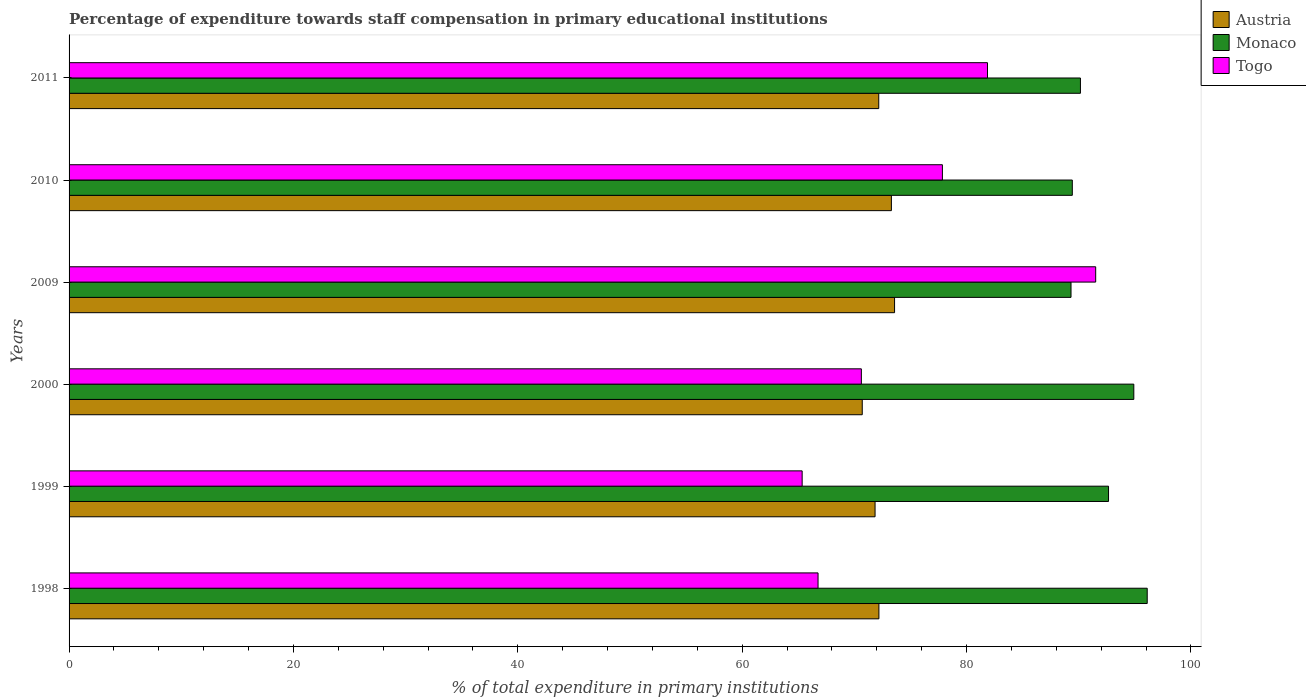How many different coloured bars are there?
Keep it short and to the point. 3. Are the number of bars per tick equal to the number of legend labels?
Make the answer very short. Yes. How many bars are there on the 1st tick from the bottom?
Your answer should be compact. 3. What is the label of the 2nd group of bars from the top?
Provide a succinct answer. 2010. In how many cases, is the number of bars for a given year not equal to the number of legend labels?
Provide a succinct answer. 0. What is the percentage of expenditure towards staff compensation in Monaco in 2000?
Offer a terse response. 94.91. Across all years, what is the maximum percentage of expenditure towards staff compensation in Austria?
Offer a terse response. 73.58. Across all years, what is the minimum percentage of expenditure towards staff compensation in Togo?
Offer a very short reply. 65.34. What is the total percentage of expenditure towards staff compensation in Togo in the graph?
Your answer should be very brief. 453.95. What is the difference between the percentage of expenditure towards staff compensation in Monaco in 2000 and that in 2011?
Keep it short and to the point. 4.76. What is the difference between the percentage of expenditure towards staff compensation in Togo in 2010 and the percentage of expenditure towards staff compensation in Monaco in 2009?
Your answer should be very brief. -11.46. What is the average percentage of expenditure towards staff compensation in Togo per year?
Offer a very short reply. 75.66. In the year 1999, what is the difference between the percentage of expenditure towards staff compensation in Togo and percentage of expenditure towards staff compensation in Austria?
Offer a very short reply. -6.5. What is the ratio of the percentage of expenditure towards staff compensation in Monaco in 2000 to that in 2011?
Provide a short and direct response. 1.05. Is the percentage of expenditure towards staff compensation in Togo in 1998 less than that in 2011?
Offer a very short reply. Yes. Is the difference between the percentage of expenditure towards staff compensation in Togo in 1998 and 2009 greater than the difference between the percentage of expenditure towards staff compensation in Austria in 1998 and 2009?
Your answer should be very brief. No. What is the difference between the highest and the second highest percentage of expenditure towards staff compensation in Austria?
Offer a very short reply. 0.28. What is the difference between the highest and the lowest percentage of expenditure towards staff compensation in Austria?
Provide a succinct answer. 2.88. In how many years, is the percentage of expenditure towards staff compensation in Togo greater than the average percentage of expenditure towards staff compensation in Togo taken over all years?
Your answer should be very brief. 3. Is the sum of the percentage of expenditure towards staff compensation in Austria in 1999 and 2000 greater than the maximum percentage of expenditure towards staff compensation in Monaco across all years?
Make the answer very short. Yes. What does the 1st bar from the top in 2010 represents?
Give a very brief answer. Togo. Is it the case that in every year, the sum of the percentage of expenditure towards staff compensation in Togo and percentage of expenditure towards staff compensation in Monaco is greater than the percentage of expenditure towards staff compensation in Austria?
Your response must be concise. Yes. How many years are there in the graph?
Offer a terse response. 6. Does the graph contain any zero values?
Make the answer very short. No. Does the graph contain grids?
Provide a short and direct response. No. How are the legend labels stacked?
Keep it short and to the point. Vertical. What is the title of the graph?
Make the answer very short. Percentage of expenditure towards staff compensation in primary educational institutions. What is the label or title of the X-axis?
Provide a succinct answer. % of total expenditure in primary institutions. What is the % of total expenditure in primary institutions in Austria in 1998?
Offer a very short reply. 72.19. What is the % of total expenditure in primary institutions of Monaco in 1998?
Your response must be concise. 96.1. What is the % of total expenditure in primary institutions in Togo in 1998?
Offer a very short reply. 66.76. What is the % of total expenditure in primary institutions of Austria in 1999?
Give a very brief answer. 71.84. What is the % of total expenditure in primary institutions in Monaco in 1999?
Your answer should be compact. 92.65. What is the % of total expenditure in primary institutions of Togo in 1999?
Make the answer very short. 65.34. What is the % of total expenditure in primary institutions in Austria in 2000?
Keep it short and to the point. 70.7. What is the % of total expenditure in primary institutions of Monaco in 2000?
Ensure brevity in your answer.  94.91. What is the % of total expenditure in primary institutions in Togo in 2000?
Make the answer very short. 70.62. What is the % of total expenditure in primary institutions in Austria in 2009?
Give a very brief answer. 73.58. What is the % of total expenditure in primary institutions in Monaco in 2009?
Provide a succinct answer. 89.31. What is the % of total expenditure in primary institutions in Togo in 2009?
Give a very brief answer. 91.51. What is the % of total expenditure in primary institutions in Austria in 2010?
Provide a short and direct response. 73.3. What is the % of total expenditure in primary institutions in Monaco in 2010?
Make the answer very short. 89.43. What is the % of total expenditure in primary institutions of Togo in 2010?
Give a very brief answer. 77.85. What is the % of total expenditure in primary institutions of Austria in 2011?
Your answer should be very brief. 72.17. What is the % of total expenditure in primary institutions in Monaco in 2011?
Offer a terse response. 90.15. What is the % of total expenditure in primary institutions of Togo in 2011?
Offer a terse response. 81.87. Across all years, what is the maximum % of total expenditure in primary institutions of Austria?
Keep it short and to the point. 73.58. Across all years, what is the maximum % of total expenditure in primary institutions in Monaco?
Offer a terse response. 96.1. Across all years, what is the maximum % of total expenditure in primary institutions of Togo?
Ensure brevity in your answer.  91.51. Across all years, what is the minimum % of total expenditure in primary institutions in Austria?
Provide a succinct answer. 70.7. Across all years, what is the minimum % of total expenditure in primary institutions of Monaco?
Provide a succinct answer. 89.31. Across all years, what is the minimum % of total expenditure in primary institutions in Togo?
Give a very brief answer. 65.34. What is the total % of total expenditure in primary institutions of Austria in the graph?
Provide a succinct answer. 433.79. What is the total % of total expenditure in primary institutions in Monaco in the graph?
Your answer should be very brief. 552.55. What is the total % of total expenditure in primary institutions of Togo in the graph?
Make the answer very short. 453.95. What is the difference between the % of total expenditure in primary institutions of Austria in 1998 and that in 1999?
Provide a short and direct response. 0.34. What is the difference between the % of total expenditure in primary institutions of Monaco in 1998 and that in 1999?
Keep it short and to the point. 3.45. What is the difference between the % of total expenditure in primary institutions of Togo in 1998 and that in 1999?
Give a very brief answer. 1.42. What is the difference between the % of total expenditure in primary institutions of Austria in 1998 and that in 2000?
Give a very brief answer. 1.49. What is the difference between the % of total expenditure in primary institutions of Monaco in 1998 and that in 2000?
Provide a short and direct response. 1.2. What is the difference between the % of total expenditure in primary institutions in Togo in 1998 and that in 2000?
Give a very brief answer. -3.86. What is the difference between the % of total expenditure in primary institutions in Austria in 1998 and that in 2009?
Provide a succinct answer. -1.4. What is the difference between the % of total expenditure in primary institutions of Monaco in 1998 and that in 2009?
Provide a short and direct response. 6.79. What is the difference between the % of total expenditure in primary institutions in Togo in 1998 and that in 2009?
Offer a terse response. -24.75. What is the difference between the % of total expenditure in primary institutions in Austria in 1998 and that in 2010?
Provide a short and direct response. -1.11. What is the difference between the % of total expenditure in primary institutions in Monaco in 1998 and that in 2010?
Give a very brief answer. 6.68. What is the difference between the % of total expenditure in primary institutions of Togo in 1998 and that in 2010?
Your answer should be very brief. -11.08. What is the difference between the % of total expenditure in primary institutions of Austria in 1998 and that in 2011?
Your answer should be very brief. 0.02. What is the difference between the % of total expenditure in primary institutions of Monaco in 1998 and that in 2011?
Give a very brief answer. 5.95. What is the difference between the % of total expenditure in primary institutions of Togo in 1998 and that in 2011?
Keep it short and to the point. -15.1. What is the difference between the % of total expenditure in primary institutions in Austria in 1999 and that in 2000?
Your response must be concise. 1.14. What is the difference between the % of total expenditure in primary institutions in Monaco in 1999 and that in 2000?
Provide a succinct answer. -2.25. What is the difference between the % of total expenditure in primary institutions of Togo in 1999 and that in 2000?
Keep it short and to the point. -5.28. What is the difference between the % of total expenditure in primary institutions in Austria in 1999 and that in 2009?
Provide a succinct answer. -1.74. What is the difference between the % of total expenditure in primary institutions of Monaco in 1999 and that in 2009?
Ensure brevity in your answer.  3.34. What is the difference between the % of total expenditure in primary institutions in Togo in 1999 and that in 2009?
Keep it short and to the point. -26.17. What is the difference between the % of total expenditure in primary institutions in Austria in 1999 and that in 2010?
Make the answer very short. -1.46. What is the difference between the % of total expenditure in primary institutions in Monaco in 1999 and that in 2010?
Give a very brief answer. 3.23. What is the difference between the % of total expenditure in primary institutions in Togo in 1999 and that in 2010?
Your answer should be very brief. -12.5. What is the difference between the % of total expenditure in primary institutions of Austria in 1999 and that in 2011?
Make the answer very short. -0.33. What is the difference between the % of total expenditure in primary institutions in Monaco in 1999 and that in 2011?
Give a very brief answer. 2.5. What is the difference between the % of total expenditure in primary institutions of Togo in 1999 and that in 2011?
Offer a terse response. -16.52. What is the difference between the % of total expenditure in primary institutions in Austria in 2000 and that in 2009?
Provide a short and direct response. -2.88. What is the difference between the % of total expenditure in primary institutions in Monaco in 2000 and that in 2009?
Keep it short and to the point. 5.6. What is the difference between the % of total expenditure in primary institutions in Togo in 2000 and that in 2009?
Give a very brief answer. -20.89. What is the difference between the % of total expenditure in primary institutions in Austria in 2000 and that in 2010?
Your answer should be compact. -2.6. What is the difference between the % of total expenditure in primary institutions in Monaco in 2000 and that in 2010?
Make the answer very short. 5.48. What is the difference between the % of total expenditure in primary institutions of Togo in 2000 and that in 2010?
Your answer should be very brief. -7.22. What is the difference between the % of total expenditure in primary institutions in Austria in 2000 and that in 2011?
Give a very brief answer. -1.47. What is the difference between the % of total expenditure in primary institutions of Monaco in 2000 and that in 2011?
Make the answer very short. 4.76. What is the difference between the % of total expenditure in primary institutions in Togo in 2000 and that in 2011?
Ensure brevity in your answer.  -11.24. What is the difference between the % of total expenditure in primary institutions in Austria in 2009 and that in 2010?
Ensure brevity in your answer.  0.28. What is the difference between the % of total expenditure in primary institutions of Monaco in 2009 and that in 2010?
Keep it short and to the point. -0.12. What is the difference between the % of total expenditure in primary institutions of Togo in 2009 and that in 2010?
Your response must be concise. 13.66. What is the difference between the % of total expenditure in primary institutions in Austria in 2009 and that in 2011?
Offer a very short reply. 1.41. What is the difference between the % of total expenditure in primary institutions of Monaco in 2009 and that in 2011?
Provide a succinct answer. -0.84. What is the difference between the % of total expenditure in primary institutions of Togo in 2009 and that in 2011?
Give a very brief answer. 9.64. What is the difference between the % of total expenditure in primary institutions in Austria in 2010 and that in 2011?
Provide a short and direct response. 1.13. What is the difference between the % of total expenditure in primary institutions of Monaco in 2010 and that in 2011?
Your answer should be very brief. -0.72. What is the difference between the % of total expenditure in primary institutions of Togo in 2010 and that in 2011?
Your answer should be compact. -4.02. What is the difference between the % of total expenditure in primary institutions of Austria in 1998 and the % of total expenditure in primary institutions of Monaco in 1999?
Your response must be concise. -20.47. What is the difference between the % of total expenditure in primary institutions in Austria in 1998 and the % of total expenditure in primary institutions in Togo in 1999?
Offer a terse response. 6.84. What is the difference between the % of total expenditure in primary institutions in Monaco in 1998 and the % of total expenditure in primary institutions in Togo in 1999?
Your answer should be very brief. 30.76. What is the difference between the % of total expenditure in primary institutions of Austria in 1998 and the % of total expenditure in primary institutions of Monaco in 2000?
Provide a short and direct response. -22.72. What is the difference between the % of total expenditure in primary institutions of Austria in 1998 and the % of total expenditure in primary institutions of Togo in 2000?
Offer a terse response. 1.57. What is the difference between the % of total expenditure in primary institutions of Monaco in 1998 and the % of total expenditure in primary institutions of Togo in 2000?
Make the answer very short. 25.48. What is the difference between the % of total expenditure in primary institutions in Austria in 1998 and the % of total expenditure in primary institutions in Monaco in 2009?
Your response must be concise. -17.12. What is the difference between the % of total expenditure in primary institutions in Austria in 1998 and the % of total expenditure in primary institutions in Togo in 2009?
Offer a terse response. -19.32. What is the difference between the % of total expenditure in primary institutions of Monaco in 1998 and the % of total expenditure in primary institutions of Togo in 2009?
Offer a terse response. 4.59. What is the difference between the % of total expenditure in primary institutions of Austria in 1998 and the % of total expenditure in primary institutions of Monaco in 2010?
Provide a succinct answer. -17.24. What is the difference between the % of total expenditure in primary institutions of Austria in 1998 and the % of total expenditure in primary institutions of Togo in 2010?
Provide a succinct answer. -5.66. What is the difference between the % of total expenditure in primary institutions in Monaco in 1998 and the % of total expenditure in primary institutions in Togo in 2010?
Your answer should be compact. 18.26. What is the difference between the % of total expenditure in primary institutions of Austria in 1998 and the % of total expenditure in primary institutions of Monaco in 2011?
Provide a short and direct response. -17.96. What is the difference between the % of total expenditure in primary institutions of Austria in 1998 and the % of total expenditure in primary institutions of Togo in 2011?
Give a very brief answer. -9.68. What is the difference between the % of total expenditure in primary institutions of Monaco in 1998 and the % of total expenditure in primary institutions of Togo in 2011?
Ensure brevity in your answer.  14.24. What is the difference between the % of total expenditure in primary institutions of Austria in 1999 and the % of total expenditure in primary institutions of Monaco in 2000?
Offer a terse response. -23.06. What is the difference between the % of total expenditure in primary institutions in Austria in 1999 and the % of total expenditure in primary institutions in Togo in 2000?
Keep it short and to the point. 1.22. What is the difference between the % of total expenditure in primary institutions in Monaco in 1999 and the % of total expenditure in primary institutions in Togo in 2000?
Provide a succinct answer. 22.03. What is the difference between the % of total expenditure in primary institutions of Austria in 1999 and the % of total expenditure in primary institutions of Monaco in 2009?
Make the answer very short. -17.47. What is the difference between the % of total expenditure in primary institutions of Austria in 1999 and the % of total expenditure in primary institutions of Togo in 2009?
Offer a very short reply. -19.67. What is the difference between the % of total expenditure in primary institutions of Monaco in 1999 and the % of total expenditure in primary institutions of Togo in 2009?
Offer a terse response. 1.14. What is the difference between the % of total expenditure in primary institutions of Austria in 1999 and the % of total expenditure in primary institutions of Monaco in 2010?
Ensure brevity in your answer.  -17.58. What is the difference between the % of total expenditure in primary institutions of Austria in 1999 and the % of total expenditure in primary institutions of Togo in 2010?
Provide a succinct answer. -6. What is the difference between the % of total expenditure in primary institutions in Monaco in 1999 and the % of total expenditure in primary institutions in Togo in 2010?
Provide a succinct answer. 14.81. What is the difference between the % of total expenditure in primary institutions of Austria in 1999 and the % of total expenditure in primary institutions of Monaco in 2011?
Offer a terse response. -18.31. What is the difference between the % of total expenditure in primary institutions in Austria in 1999 and the % of total expenditure in primary institutions in Togo in 2011?
Your response must be concise. -10.02. What is the difference between the % of total expenditure in primary institutions in Monaco in 1999 and the % of total expenditure in primary institutions in Togo in 2011?
Give a very brief answer. 10.79. What is the difference between the % of total expenditure in primary institutions of Austria in 2000 and the % of total expenditure in primary institutions of Monaco in 2009?
Your answer should be very brief. -18.61. What is the difference between the % of total expenditure in primary institutions of Austria in 2000 and the % of total expenditure in primary institutions of Togo in 2009?
Offer a very short reply. -20.81. What is the difference between the % of total expenditure in primary institutions in Monaco in 2000 and the % of total expenditure in primary institutions in Togo in 2009?
Make the answer very short. 3.4. What is the difference between the % of total expenditure in primary institutions of Austria in 2000 and the % of total expenditure in primary institutions of Monaco in 2010?
Keep it short and to the point. -18.72. What is the difference between the % of total expenditure in primary institutions of Austria in 2000 and the % of total expenditure in primary institutions of Togo in 2010?
Your answer should be very brief. -7.14. What is the difference between the % of total expenditure in primary institutions in Monaco in 2000 and the % of total expenditure in primary institutions in Togo in 2010?
Provide a succinct answer. 17.06. What is the difference between the % of total expenditure in primary institutions in Austria in 2000 and the % of total expenditure in primary institutions in Monaco in 2011?
Offer a very short reply. -19.45. What is the difference between the % of total expenditure in primary institutions of Austria in 2000 and the % of total expenditure in primary institutions of Togo in 2011?
Keep it short and to the point. -11.16. What is the difference between the % of total expenditure in primary institutions in Monaco in 2000 and the % of total expenditure in primary institutions in Togo in 2011?
Your answer should be compact. 13.04. What is the difference between the % of total expenditure in primary institutions in Austria in 2009 and the % of total expenditure in primary institutions in Monaco in 2010?
Ensure brevity in your answer.  -15.84. What is the difference between the % of total expenditure in primary institutions in Austria in 2009 and the % of total expenditure in primary institutions in Togo in 2010?
Ensure brevity in your answer.  -4.26. What is the difference between the % of total expenditure in primary institutions in Monaco in 2009 and the % of total expenditure in primary institutions in Togo in 2010?
Offer a very short reply. 11.46. What is the difference between the % of total expenditure in primary institutions in Austria in 2009 and the % of total expenditure in primary institutions in Monaco in 2011?
Offer a very short reply. -16.57. What is the difference between the % of total expenditure in primary institutions in Austria in 2009 and the % of total expenditure in primary institutions in Togo in 2011?
Keep it short and to the point. -8.28. What is the difference between the % of total expenditure in primary institutions of Monaco in 2009 and the % of total expenditure in primary institutions of Togo in 2011?
Keep it short and to the point. 7.45. What is the difference between the % of total expenditure in primary institutions of Austria in 2010 and the % of total expenditure in primary institutions of Monaco in 2011?
Make the answer very short. -16.85. What is the difference between the % of total expenditure in primary institutions of Austria in 2010 and the % of total expenditure in primary institutions of Togo in 2011?
Provide a succinct answer. -8.57. What is the difference between the % of total expenditure in primary institutions of Monaco in 2010 and the % of total expenditure in primary institutions of Togo in 2011?
Provide a short and direct response. 7.56. What is the average % of total expenditure in primary institutions in Austria per year?
Your answer should be compact. 72.3. What is the average % of total expenditure in primary institutions of Monaco per year?
Your response must be concise. 92.09. What is the average % of total expenditure in primary institutions in Togo per year?
Offer a very short reply. 75.66. In the year 1998, what is the difference between the % of total expenditure in primary institutions of Austria and % of total expenditure in primary institutions of Monaco?
Make the answer very short. -23.92. In the year 1998, what is the difference between the % of total expenditure in primary institutions in Austria and % of total expenditure in primary institutions in Togo?
Offer a very short reply. 5.43. In the year 1998, what is the difference between the % of total expenditure in primary institutions of Monaco and % of total expenditure in primary institutions of Togo?
Your response must be concise. 29.34. In the year 1999, what is the difference between the % of total expenditure in primary institutions of Austria and % of total expenditure in primary institutions of Monaco?
Provide a short and direct response. -20.81. In the year 1999, what is the difference between the % of total expenditure in primary institutions in Austria and % of total expenditure in primary institutions in Togo?
Ensure brevity in your answer.  6.5. In the year 1999, what is the difference between the % of total expenditure in primary institutions of Monaco and % of total expenditure in primary institutions of Togo?
Give a very brief answer. 27.31. In the year 2000, what is the difference between the % of total expenditure in primary institutions of Austria and % of total expenditure in primary institutions of Monaco?
Ensure brevity in your answer.  -24.21. In the year 2000, what is the difference between the % of total expenditure in primary institutions in Austria and % of total expenditure in primary institutions in Togo?
Offer a very short reply. 0.08. In the year 2000, what is the difference between the % of total expenditure in primary institutions of Monaco and % of total expenditure in primary institutions of Togo?
Offer a terse response. 24.29. In the year 2009, what is the difference between the % of total expenditure in primary institutions of Austria and % of total expenditure in primary institutions of Monaco?
Provide a short and direct response. -15.73. In the year 2009, what is the difference between the % of total expenditure in primary institutions in Austria and % of total expenditure in primary institutions in Togo?
Your response must be concise. -17.93. In the year 2009, what is the difference between the % of total expenditure in primary institutions in Monaco and % of total expenditure in primary institutions in Togo?
Provide a short and direct response. -2.2. In the year 2010, what is the difference between the % of total expenditure in primary institutions of Austria and % of total expenditure in primary institutions of Monaco?
Give a very brief answer. -16.13. In the year 2010, what is the difference between the % of total expenditure in primary institutions of Austria and % of total expenditure in primary institutions of Togo?
Your response must be concise. -4.55. In the year 2010, what is the difference between the % of total expenditure in primary institutions of Monaco and % of total expenditure in primary institutions of Togo?
Your answer should be compact. 11.58. In the year 2011, what is the difference between the % of total expenditure in primary institutions of Austria and % of total expenditure in primary institutions of Monaco?
Offer a very short reply. -17.98. In the year 2011, what is the difference between the % of total expenditure in primary institutions of Austria and % of total expenditure in primary institutions of Togo?
Your response must be concise. -9.69. In the year 2011, what is the difference between the % of total expenditure in primary institutions in Monaco and % of total expenditure in primary institutions in Togo?
Provide a short and direct response. 8.28. What is the ratio of the % of total expenditure in primary institutions of Monaco in 1998 to that in 1999?
Provide a succinct answer. 1.04. What is the ratio of the % of total expenditure in primary institutions in Togo in 1998 to that in 1999?
Your answer should be compact. 1.02. What is the ratio of the % of total expenditure in primary institutions of Monaco in 1998 to that in 2000?
Your answer should be very brief. 1.01. What is the ratio of the % of total expenditure in primary institutions of Togo in 1998 to that in 2000?
Keep it short and to the point. 0.95. What is the ratio of the % of total expenditure in primary institutions of Monaco in 1998 to that in 2009?
Offer a very short reply. 1.08. What is the ratio of the % of total expenditure in primary institutions of Togo in 1998 to that in 2009?
Provide a short and direct response. 0.73. What is the ratio of the % of total expenditure in primary institutions of Monaco in 1998 to that in 2010?
Make the answer very short. 1.07. What is the ratio of the % of total expenditure in primary institutions of Togo in 1998 to that in 2010?
Ensure brevity in your answer.  0.86. What is the ratio of the % of total expenditure in primary institutions in Austria in 1998 to that in 2011?
Keep it short and to the point. 1. What is the ratio of the % of total expenditure in primary institutions of Monaco in 1998 to that in 2011?
Keep it short and to the point. 1.07. What is the ratio of the % of total expenditure in primary institutions in Togo in 1998 to that in 2011?
Keep it short and to the point. 0.82. What is the ratio of the % of total expenditure in primary institutions in Austria in 1999 to that in 2000?
Ensure brevity in your answer.  1.02. What is the ratio of the % of total expenditure in primary institutions in Monaco in 1999 to that in 2000?
Provide a short and direct response. 0.98. What is the ratio of the % of total expenditure in primary institutions in Togo in 1999 to that in 2000?
Ensure brevity in your answer.  0.93. What is the ratio of the % of total expenditure in primary institutions of Austria in 1999 to that in 2009?
Your answer should be very brief. 0.98. What is the ratio of the % of total expenditure in primary institutions of Monaco in 1999 to that in 2009?
Keep it short and to the point. 1.04. What is the ratio of the % of total expenditure in primary institutions of Togo in 1999 to that in 2009?
Make the answer very short. 0.71. What is the ratio of the % of total expenditure in primary institutions of Austria in 1999 to that in 2010?
Offer a terse response. 0.98. What is the ratio of the % of total expenditure in primary institutions of Monaco in 1999 to that in 2010?
Provide a succinct answer. 1.04. What is the ratio of the % of total expenditure in primary institutions in Togo in 1999 to that in 2010?
Offer a very short reply. 0.84. What is the ratio of the % of total expenditure in primary institutions of Austria in 1999 to that in 2011?
Give a very brief answer. 1. What is the ratio of the % of total expenditure in primary institutions of Monaco in 1999 to that in 2011?
Keep it short and to the point. 1.03. What is the ratio of the % of total expenditure in primary institutions in Togo in 1999 to that in 2011?
Give a very brief answer. 0.8. What is the ratio of the % of total expenditure in primary institutions in Austria in 2000 to that in 2009?
Provide a succinct answer. 0.96. What is the ratio of the % of total expenditure in primary institutions of Monaco in 2000 to that in 2009?
Provide a short and direct response. 1.06. What is the ratio of the % of total expenditure in primary institutions of Togo in 2000 to that in 2009?
Your answer should be compact. 0.77. What is the ratio of the % of total expenditure in primary institutions of Austria in 2000 to that in 2010?
Offer a terse response. 0.96. What is the ratio of the % of total expenditure in primary institutions in Monaco in 2000 to that in 2010?
Your response must be concise. 1.06. What is the ratio of the % of total expenditure in primary institutions in Togo in 2000 to that in 2010?
Your answer should be very brief. 0.91. What is the ratio of the % of total expenditure in primary institutions of Austria in 2000 to that in 2011?
Your answer should be compact. 0.98. What is the ratio of the % of total expenditure in primary institutions of Monaco in 2000 to that in 2011?
Provide a succinct answer. 1.05. What is the ratio of the % of total expenditure in primary institutions of Togo in 2000 to that in 2011?
Offer a terse response. 0.86. What is the ratio of the % of total expenditure in primary institutions in Austria in 2009 to that in 2010?
Provide a short and direct response. 1. What is the ratio of the % of total expenditure in primary institutions of Monaco in 2009 to that in 2010?
Provide a short and direct response. 1. What is the ratio of the % of total expenditure in primary institutions of Togo in 2009 to that in 2010?
Offer a terse response. 1.18. What is the ratio of the % of total expenditure in primary institutions in Austria in 2009 to that in 2011?
Provide a short and direct response. 1.02. What is the ratio of the % of total expenditure in primary institutions in Monaco in 2009 to that in 2011?
Your answer should be compact. 0.99. What is the ratio of the % of total expenditure in primary institutions of Togo in 2009 to that in 2011?
Ensure brevity in your answer.  1.12. What is the ratio of the % of total expenditure in primary institutions of Austria in 2010 to that in 2011?
Offer a very short reply. 1.02. What is the ratio of the % of total expenditure in primary institutions of Togo in 2010 to that in 2011?
Make the answer very short. 0.95. What is the difference between the highest and the second highest % of total expenditure in primary institutions of Austria?
Offer a very short reply. 0.28. What is the difference between the highest and the second highest % of total expenditure in primary institutions of Monaco?
Provide a succinct answer. 1.2. What is the difference between the highest and the second highest % of total expenditure in primary institutions in Togo?
Provide a succinct answer. 9.64. What is the difference between the highest and the lowest % of total expenditure in primary institutions of Austria?
Offer a very short reply. 2.88. What is the difference between the highest and the lowest % of total expenditure in primary institutions of Monaco?
Your answer should be very brief. 6.79. What is the difference between the highest and the lowest % of total expenditure in primary institutions of Togo?
Your answer should be compact. 26.17. 